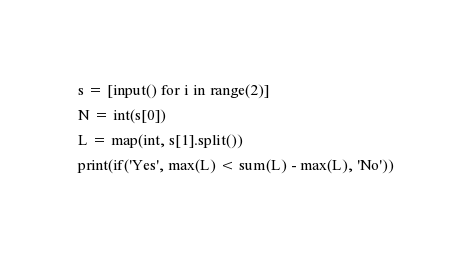<code> <loc_0><loc_0><loc_500><loc_500><_Python_>s = [input() for i in range(2)]
N = int(s[0])
L = map(int, s[1].split())
print(if('Yes', max(L) < sum(L) - max(L), 'No'))</code> 